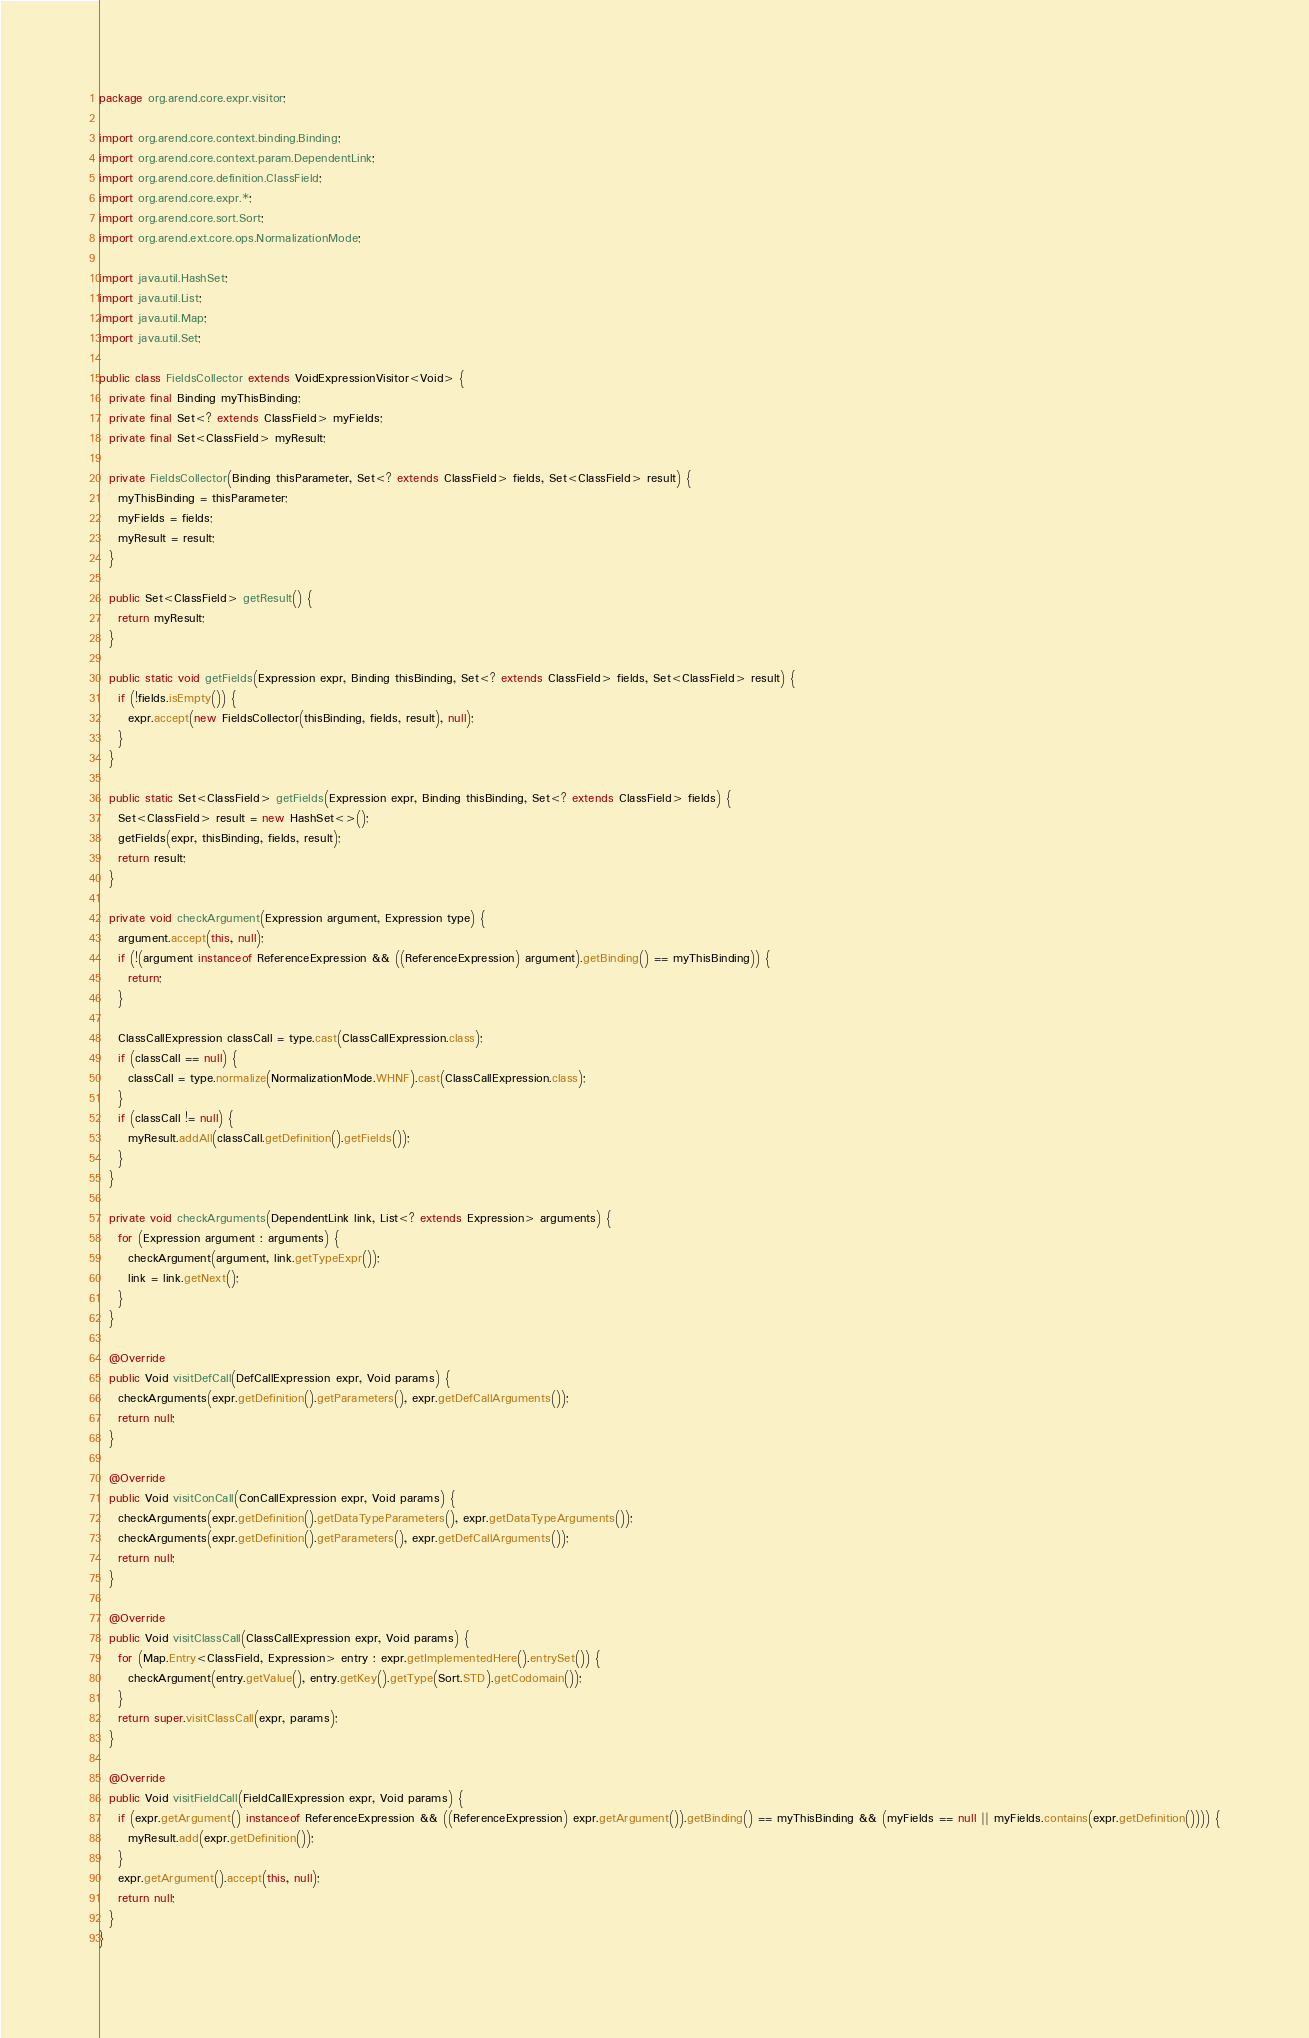Convert code to text. <code><loc_0><loc_0><loc_500><loc_500><_Java_>package org.arend.core.expr.visitor;

import org.arend.core.context.binding.Binding;
import org.arend.core.context.param.DependentLink;
import org.arend.core.definition.ClassField;
import org.arend.core.expr.*;
import org.arend.core.sort.Sort;
import org.arend.ext.core.ops.NormalizationMode;

import java.util.HashSet;
import java.util.List;
import java.util.Map;
import java.util.Set;

public class FieldsCollector extends VoidExpressionVisitor<Void> {
  private final Binding myThisBinding;
  private final Set<? extends ClassField> myFields;
  private final Set<ClassField> myResult;

  private FieldsCollector(Binding thisParameter, Set<? extends ClassField> fields, Set<ClassField> result) {
    myThisBinding = thisParameter;
    myFields = fields;
    myResult = result;
  }

  public Set<ClassField> getResult() {
    return myResult;
  }

  public static void getFields(Expression expr, Binding thisBinding, Set<? extends ClassField> fields, Set<ClassField> result) {
    if (!fields.isEmpty()) {
      expr.accept(new FieldsCollector(thisBinding, fields, result), null);
    }
  }

  public static Set<ClassField> getFields(Expression expr, Binding thisBinding, Set<? extends ClassField> fields) {
    Set<ClassField> result = new HashSet<>();
    getFields(expr, thisBinding, fields, result);
    return result;
  }

  private void checkArgument(Expression argument, Expression type) {
    argument.accept(this, null);
    if (!(argument instanceof ReferenceExpression && ((ReferenceExpression) argument).getBinding() == myThisBinding)) {
      return;
    }

    ClassCallExpression classCall = type.cast(ClassCallExpression.class);
    if (classCall == null) {
      classCall = type.normalize(NormalizationMode.WHNF).cast(ClassCallExpression.class);
    }
    if (classCall != null) {
      myResult.addAll(classCall.getDefinition().getFields());
    }
  }

  private void checkArguments(DependentLink link, List<? extends Expression> arguments) {
    for (Expression argument : arguments) {
      checkArgument(argument, link.getTypeExpr());
      link = link.getNext();
    }
  }

  @Override
  public Void visitDefCall(DefCallExpression expr, Void params) {
    checkArguments(expr.getDefinition().getParameters(), expr.getDefCallArguments());
    return null;
  }

  @Override
  public Void visitConCall(ConCallExpression expr, Void params) {
    checkArguments(expr.getDefinition().getDataTypeParameters(), expr.getDataTypeArguments());
    checkArguments(expr.getDefinition().getParameters(), expr.getDefCallArguments());
    return null;
  }

  @Override
  public Void visitClassCall(ClassCallExpression expr, Void params) {
    for (Map.Entry<ClassField, Expression> entry : expr.getImplementedHere().entrySet()) {
      checkArgument(entry.getValue(), entry.getKey().getType(Sort.STD).getCodomain());
    }
    return super.visitClassCall(expr, params);
  }

  @Override
  public Void visitFieldCall(FieldCallExpression expr, Void params) {
    if (expr.getArgument() instanceof ReferenceExpression && ((ReferenceExpression) expr.getArgument()).getBinding() == myThisBinding && (myFields == null || myFields.contains(expr.getDefinition()))) {
      myResult.add(expr.getDefinition());
    }
    expr.getArgument().accept(this, null);
    return null;
  }
}
</code> 